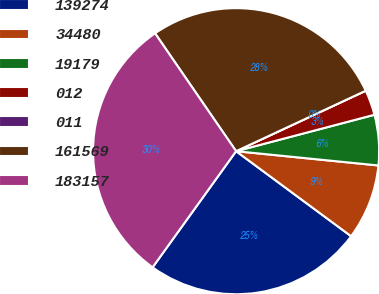Convert chart to OTSL. <chart><loc_0><loc_0><loc_500><loc_500><pie_chart><fcel>139274<fcel>34480<fcel>19179<fcel>012<fcel>011<fcel>161569<fcel>183157<nl><fcel>24.79%<fcel>8.54%<fcel>5.69%<fcel>2.85%<fcel>0.0%<fcel>27.64%<fcel>30.49%<nl></chart> 